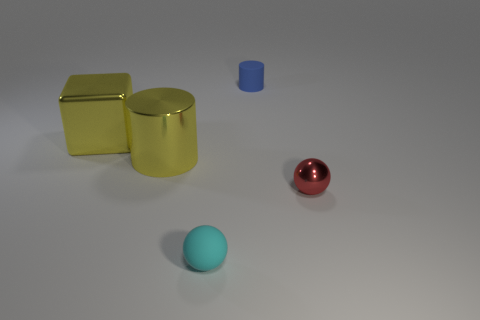There is a large object that is the same color as the large metal cube; what is its shape?
Give a very brief answer. Cylinder. There is a cyan object that is the same size as the blue matte cylinder; what shape is it?
Offer a very short reply. Sphere. How many large things have the same color as the large shiny cube?
Keep it short and to the point. 1. Are the sphere left of the rubber cylinder and the large cube made of the same material?
Your answer should be very brief. No. There is a blue object; what shape is it?
Offer a very short reply. Cylinder. How many purple objects are matte balls or tiny rubber cylinders?
Offer a very short reply. 0. What number of other objects are the same material as the tiny blue object?
Your response must be concise. 1. There is a tiny thing in front of the small red thing; is it the same shape as the tiny metal thing?
Offer a very short reply. Yes. Is there a cyan thing?
Keep it short and to the point. Yes. Is the number of small rubber things that are behind the cube greater than the number of gray matte cylinders?
Keep it short and to the point. Yes. 